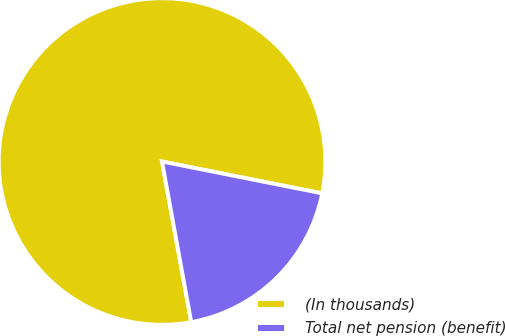<chart> <loc_0><loc_0><loc_500><loc_500><pie_chart><fcel>(In thousands)<fcel>Total net pension (benefit)<nl><fcel>80.99%<fcel>19.01%<nl></chart> 